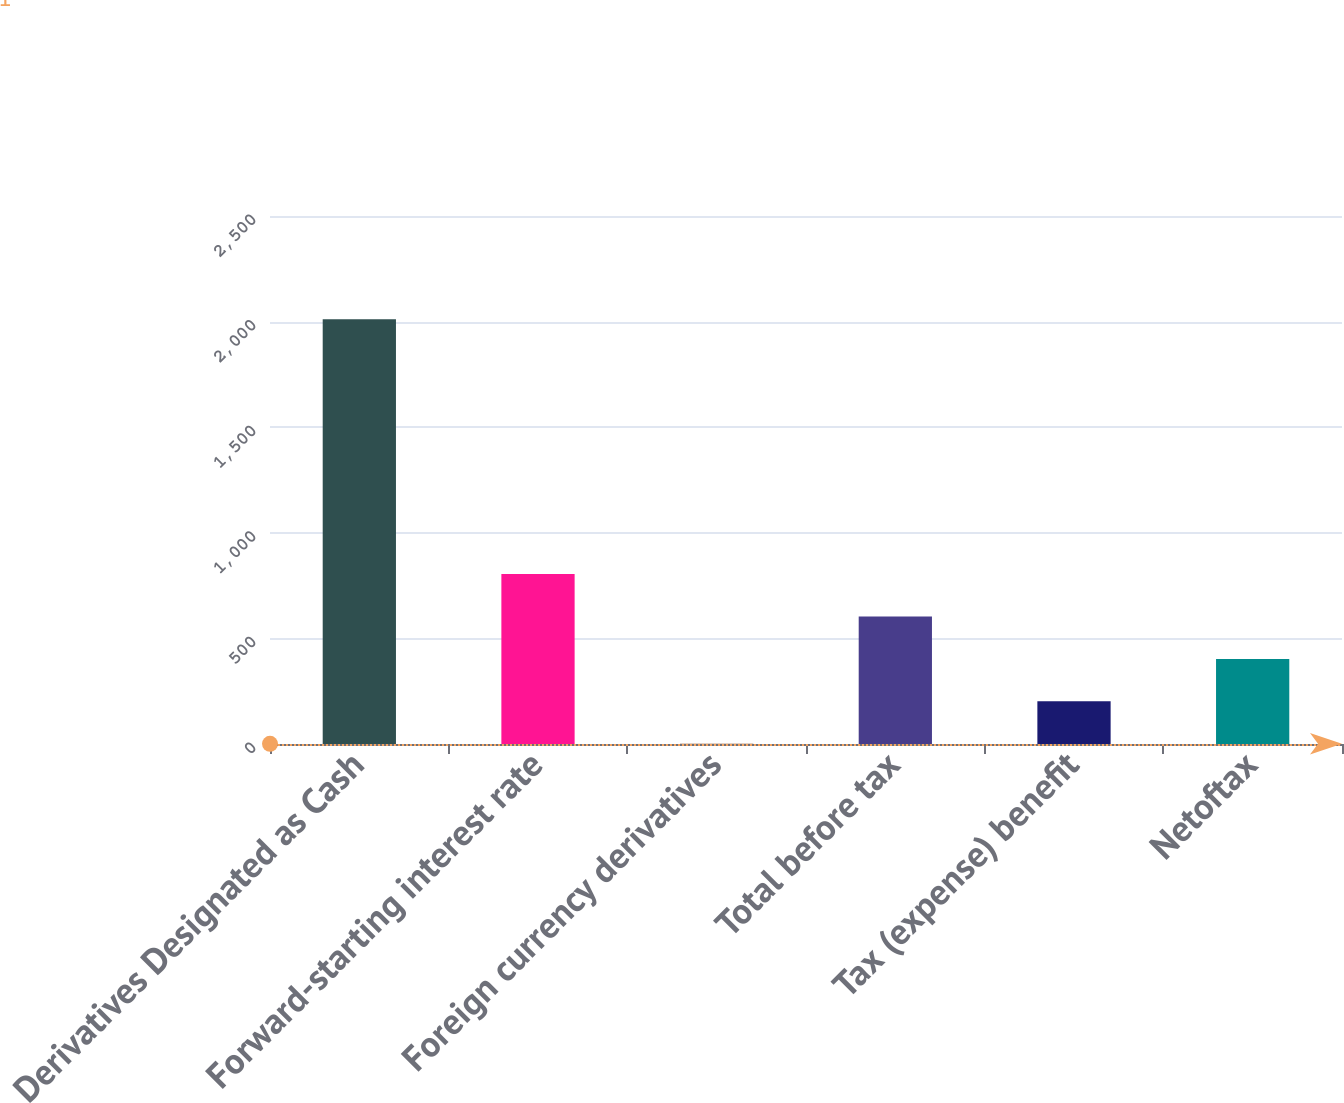Convert chart to OTSL. <chart><loc_0><loc_0><loc_500><loc_500><bar_chart><fcel>Derivatives Designated as Cash<fcel>Forward-starting interest rate<fcel>Foreign currency derivatives<fcel>Total before tax<fcel>Tax (expense) benefit<fcel>Netoftax<nl><fcel>2011<fcel>805<fcel>1<fcel>604<fcel>202<fcel>403<nl></chart> 